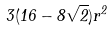Convert formula to latex. <formula><loc_0><loc_0><loc_500><loc_500>3 ( 1 6 - 8 \sqrt { 2 } ) r ^ { 2 }</formula> 